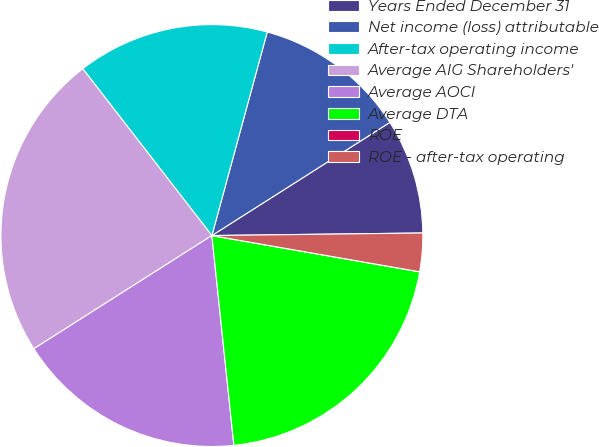Convert chart. <chart><loc_0><loc_0><loc_500><loc_500><pie_chart><fcel>Years Ended December 31<fcel>Net income (loss) attributable<fcel>After-tax operating income<fcel>Average AIG Shareholders'<fcel>Average AOCI<fcel>Average DTA<fcel>ROE<fcel>ROE - after-tax operating<nl><fcel>8.82%<fcel>11.76%<fcel>14.71%<fcel>23.53%<fcel>17.65%<fcel>20.59%<fcel>0.0%<fcel>2.94%<nl></chart> 